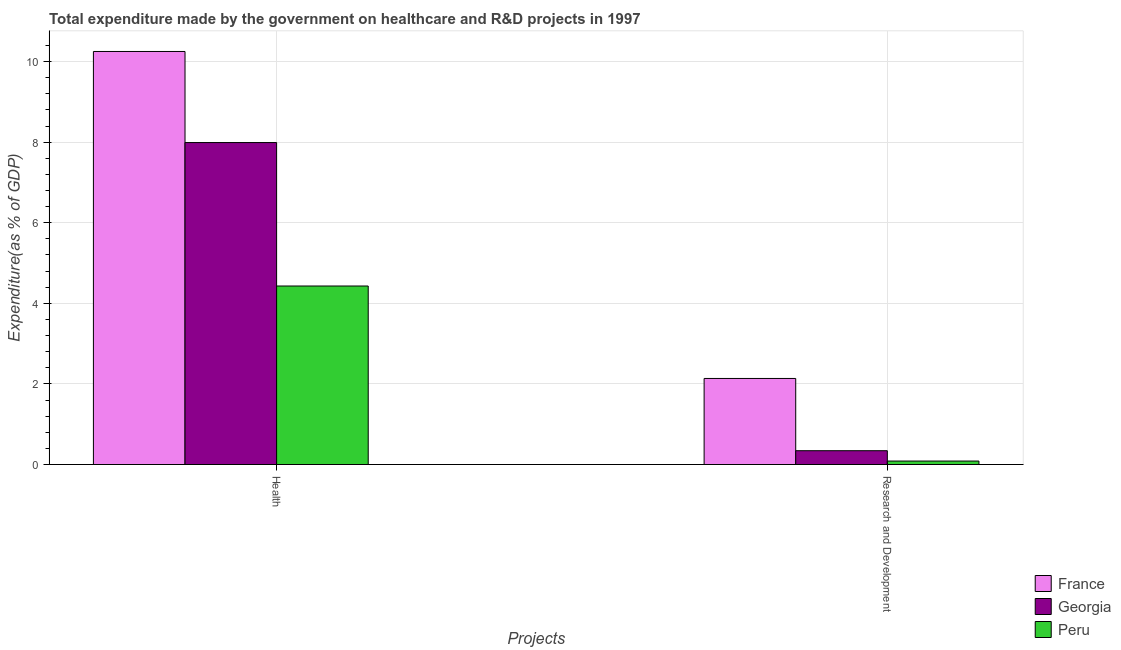How many different coloured bars are there?
Your response must be concise. 3. How many groups of bars are there?
Give a very brief answer. 2. What is the label of the 2nd group of bars from the left?
Provide a short and direct response. Research and Development. What is the expenditure in r&d in Georgia?
Offer a terse response. 0.34. Across all countries, what is the maximum expenditure in healthcare?
Offer a very short reply. 10.25. Across all countries, what is the minimum expenditure in r&d?
Offer a terse response. 0.09. In which country was the expenditure in r&d maximum?
Make the answer very short. France. What is the total expenditure in r&d in the graph?
Make the answer very short. 2.56. What is the difference between the expenditure in r&d in France and that in Peru?
Your answer should be very brief. 2.05. What is the difference between the expenditure in healthcare in France and the expenditure in r&d in Georgia?
Provide a short and direct response. 9.91. What is the average expenditure in r&d per country?
Offer a terse response. 0.85. What is the difference between the expenditure in healthcare and expenditure in r&d in France?
Your answer should be very brief. 8.11. What is the ratio of the expenditure in r&d in Peru to that in France?
Give a very brief answer. 0.04. In how many countries, is the expenditure in r&d greater than the average expenditure in r&d taken over all countries?
Offer a terse response. 1. What does the 2nd bar from the left in Health represents?
Ensure brevity in your answer.  Georgia. How many bars are there?
Keep it short and to the point. 6. Are all the bars in the graph horizontal?
Your answer should be compact. No. Does the graph contain any zero values?
Keep it short and to the point. No. Where does the legend appear in the graph?
Offer a very short reply. Bottom right. How are the legend labels stacked?
Ensure brevity in your answer.  Vertical. What is the title of the graph?
Offer a terse response. Total expenditure made by the government on healthcare and R&D projects in 1997. What is the label or title of the X-axis?
Make the answer very short. Projects. What is the label or title of the Y-axis?
Keep it short and to the point. Expenditure(as % of GDP). What is the Expenditure(as % of GDP) in France in Health?
Offer a very short reply. 10.25. What is the Expenditure(as % of GDP) of Georgia in Health?
Keep it short and to the point. 7.99. What is the Expenditure(as % of GDP) in Peru in Health?
Give a very brief answer. 4.43. What is the Expenditure(as % of GDP) of France in Research and Development?
Your answer should be compact. 2.14. What is the Expenditure(as % of GDP) in Georgia in Research and Development?
Make the answer very short. 0.34. What is the Expenditure(as % of GDP) in Peru in Research and Development?
Give a very brief answer. 0.09. Across all Projects, what is the maximum Expenditure(as % of GDP) in France?
Offer a terse response. 10.25. Across all Projects, what is the maximum Expenditure(as % of GDP) of Georgia?
Offer a terse response. 7.99. Across all Projects, what is the maximum Expenditure(as % of GDP) in Peru?
Your answer should be very brief. 4.43. Across all Projects, what is the minimum Expenditure(as % of GDP) of France?
Offer a terse response. 2.14. Across all Projects, what is the minimum Expenditure(as % of GDP) in Georgia?
Your answer should be compact. 0.34. Across all Projects, what is the minimum Expenditure(as % of GDP) in Peru?
Your response must be concise. 0.09. What is the total Expenditure(as % of GDP) of France in the graph?
Keep it short and to the point. 12.39. What is the total Expenditure(as % of GDP) of Georgia in the graph?
Keep it short and to the point. 8.33. What is the total Expenditure(as % of GDP) of Peru in the graph?
Provide a short and direct response. 4.52. What is the difference between the Expenditure(as % of GDP) in France in Health and that in Research and Development?
Make the answer very short. 8.11. What is the difference between the Expenditure(as % of GDP) in Georgia in Health and that in Research and Development?
Provide a succinct answer. 7.65. What is the difference between the Expenditure(as % of GDP) in Peru in Health and that in Research and Development?
Your response must be concise. 4.34. What is the difference between the Expenditure(as % of GDP) of France in Health and the Expenditure(as % of GDP) of Georgia in Research and Development?
Give a very brief answer. 9.91. What is the difference between the Expenditure(as % of GDP) of France in Health and the Expenditure(as % of GDP) of Peru in Research and Development?
Offer a terse response. 10.16. What is the difference between the Expenditure(as % of GDP) of Georgia in Health and the Expenditure(as % of GDP) of Peru in Research and Development?
Give a very brief answer. 7.9. What is the average Expenditure(as % of GDP) in France per Projects?
Ensure brevity in your answer.  6.19. What is the average Expenditure(as % of GDP) of Georgia per Projects?
Your answer should be very brief. 4.17. What is the average Expenditure(as % of GDP) in Peru per Projects?
Provide a short and direct response. 2.26. What is the difference between the Expenditure(as % of GDP) in France and Expenditure(as % of GDP) in Georgia in Health?
Give a very brief answer. 2.26. What is the difference between the Expenditure(as % of GDP) in France and Expenditure(as % of GDP) in Peru in Health?
Keep it short and to the point. 5.82. What is the difference between the Expenditure(as % of GDP) in Georgia and Expenditure(as % of GDP) in Peru in Health?
Your response must be concise. 3.56. What is the difference between the Expenditure(as % of GDP) in France and Expenditure(as % of GDP) in Georgia in Research and Development?
Give a very brief answer. 1.79. What is the difference between the Expenditure(as % of GDP) of France and Expenditure(as % of GDP) of Peru in Research and Development?
Ensure brevity in your answer.  2.05. What is the difference between the Expenditure(as % of GDP) in Georgia and Expenditure(as % of GDP) in Peru in Research and Development?
Provide a succinct answer. 0.26. What is the ratio of the Expenditure(as % of GDP) in Georgia in Health to that in Research and Development?
Your response must be concise. 23.33. What is the ratio of the Expenditure(as % of GDP) in Peru in Health to that in Research and Development?
Your answer should be very brief. 51.79. What is the difference between the highest and the second highest Expenditure(as % of GDP) in France?
Give a very brief answer. 8.11. What is the difference between the highest and the second highest Expenditure(as % of GDP) in Georgia?
Your response must be concise. 7.65. What is the difference between the highest and the second highest Expenditure(as % of GDP) in Peru?
Keep it short and to the point. 4.34. What is the difference between the highest and the lowest Expenditure(as % of GDP) in France?
Your answer should be very brief. 8.11. What is the difference between the highest and the lowest Expenditure(as % of GDP) of Georgia?
Your answer should be compact. 7.65. What is the difference between the highest and the lowest Expenditure(as % of GDP) of Peru?
Ensure brevity in your answer.  4.34. 